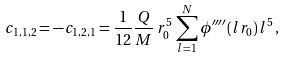Convert formula to latex. <formula><loc_0><loc_0><loc_500><loc_500>c _ { 1 , 1 , 2 } = - c _ { 1 , 2 , 1 } = \frac { 1 } { 1 2 } \frac { Q } { M } \, r _ { 0 } ^ { 5 } \, \sum _ { l = 1 } ^ { N } \phi ^ { \prime \prime \prime \prime } ( l r _ { 0 } ) \, l ^ { 5 } \, ,</formula> 